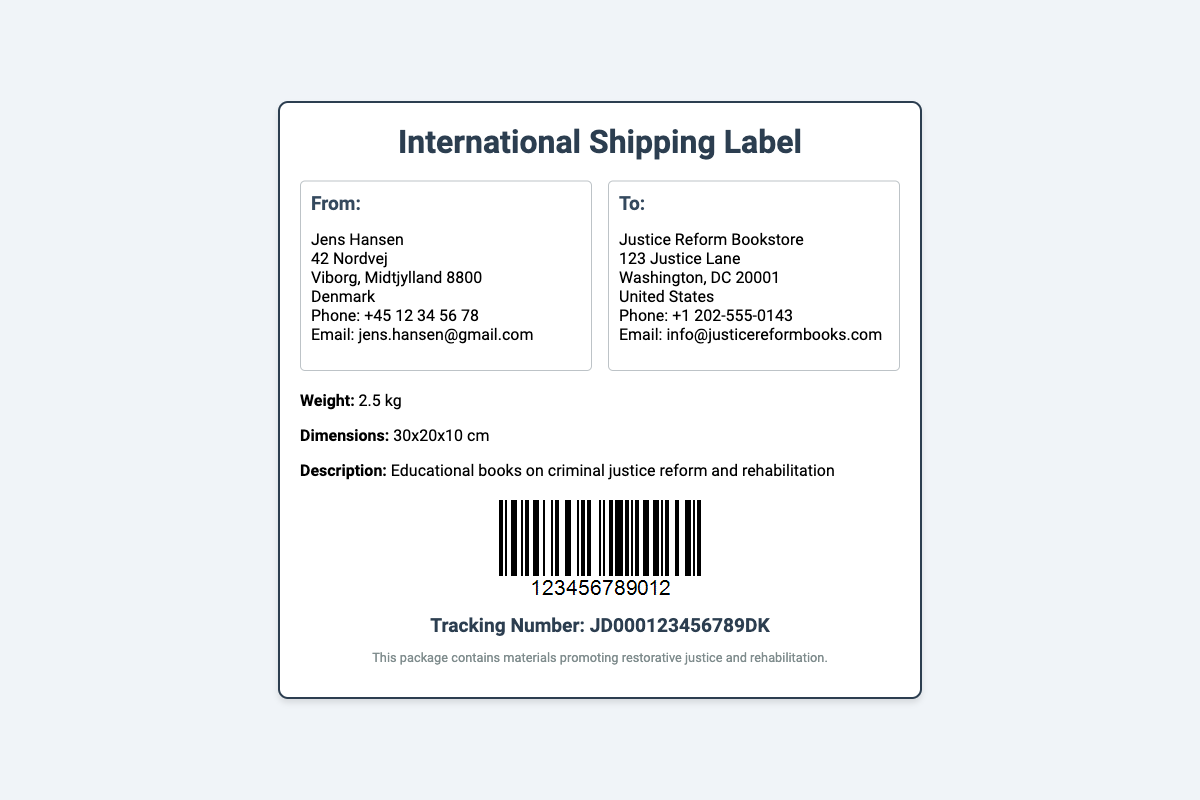What is the sender's name? The sender's name is listed at the top of the "From" section of the label.
Answer: Jens Hansen What is the recipient's email? The recipient's email is found in the "To" section under the address details.
Answer: info@justicereformbooks.com What is the weight of the package? The weight is specified in the package details section of the document.
Answer: 2.5 kg What is the tracking number? The tracking number is provided in the tracking section of the shipping label.
Answer: JD000123456789DK What type of books are being shipped? The description of the package includes details about the contents being shipped.
Answer: Educational books on criminal justice reform and rehabilitation Where is the package being sent to? The destination address, along with the organization name, is in the "To" section.
Answer: Justice Reform Bookstore What is the sender's phone number? The sender's phone number is located in the "From" section of the label.
Answer: +45 12 34 56 78 Which country is the sender located in? The country is mentioned in the "From" section of the document.
Answer: Denmark What image is displayed on the label? An image depicting a barcode is specified in the barcode section of the document.
Answer: Barcode What is the purpose of the package? The purpose is highlighted in the footer section of the document.
Answer: Materials promoting restorative justice and rehabilitation 